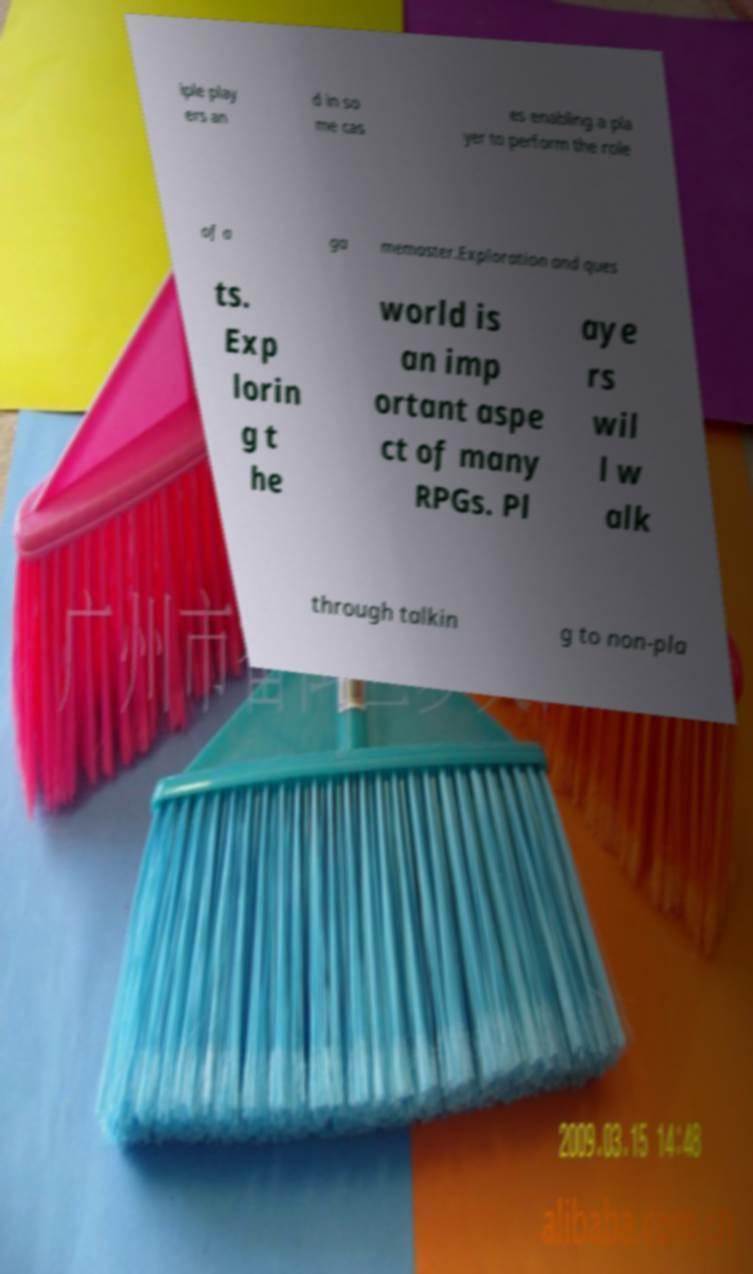Could you extract and type out the text from this image? iple play ers an d in so me cas es enabling a pla yer to perform the role of a ga memaster.Exploration and ques ts. Exp lorin g t he world is an imp ortant aspe ct of many RPGs. Pl aye rs wil l w alk through talkin g to non-pla 